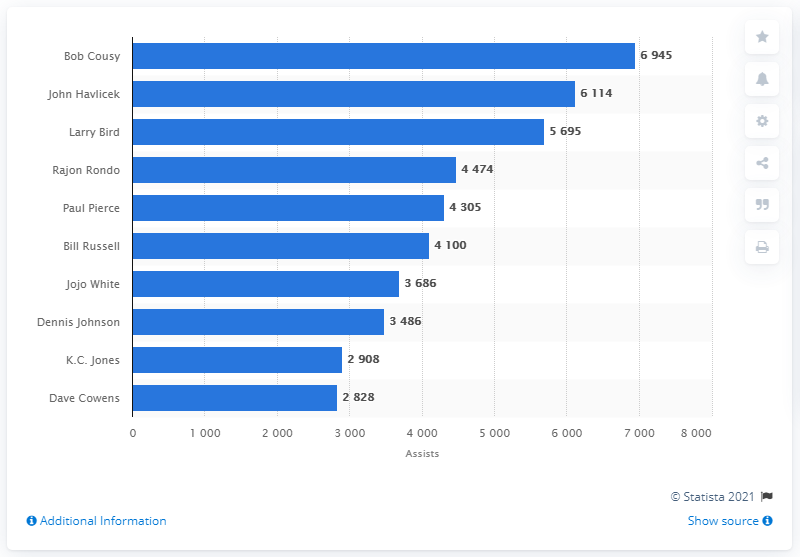Identify some key points in this picture. The career assists leader of the Boston Celtics is Bob Cousy. 